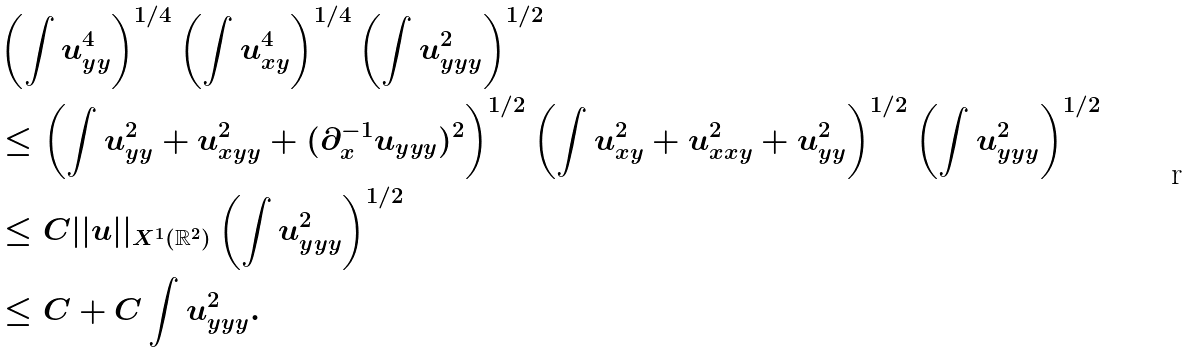Convert formula to latex. <formula><loc_0><loc_0><loc_500><loc_500>& \left ( \int u _ { y y } ^ { 4 } \right ) ^ { 1 / 4 } \left ( \int u _ { x y } ^ { 4 } \right ) ^ { 1 / 4 } \left ( \int u _ { y y y } ^ { 2 } \right ) ^ { 1 / 2 } \\ & \leq \left ( \int u _ { y y } ^ { 2 } + u _ { x y y } ^ { 2 } + ( \partial _ { x } ^ { - 1 } u _ { y y y } ) ^ { 2 } \right ) ^ { 1 / 2 } \left ( \int u _ { x y } ^ { 2 } + u _ { x x y } ^ { 2 } + u _ { y y } ^ { 2 } \right ) ^ { 1 / 2 } \left ( \int u _ { y y y } ^ { 2 } \right ) ^ { 1 / 2 } \\ & \leq C | | u | | _ { X ^ { 1 } ( \mathbb { R } ^ { 2 } ) } \left ( \int u _ { y y y } ^ { 2 } \right ) ^ { 1 / 2 } \\ & \leq C + C \int u _ { y y y } ^ { 2 } .</formula> 